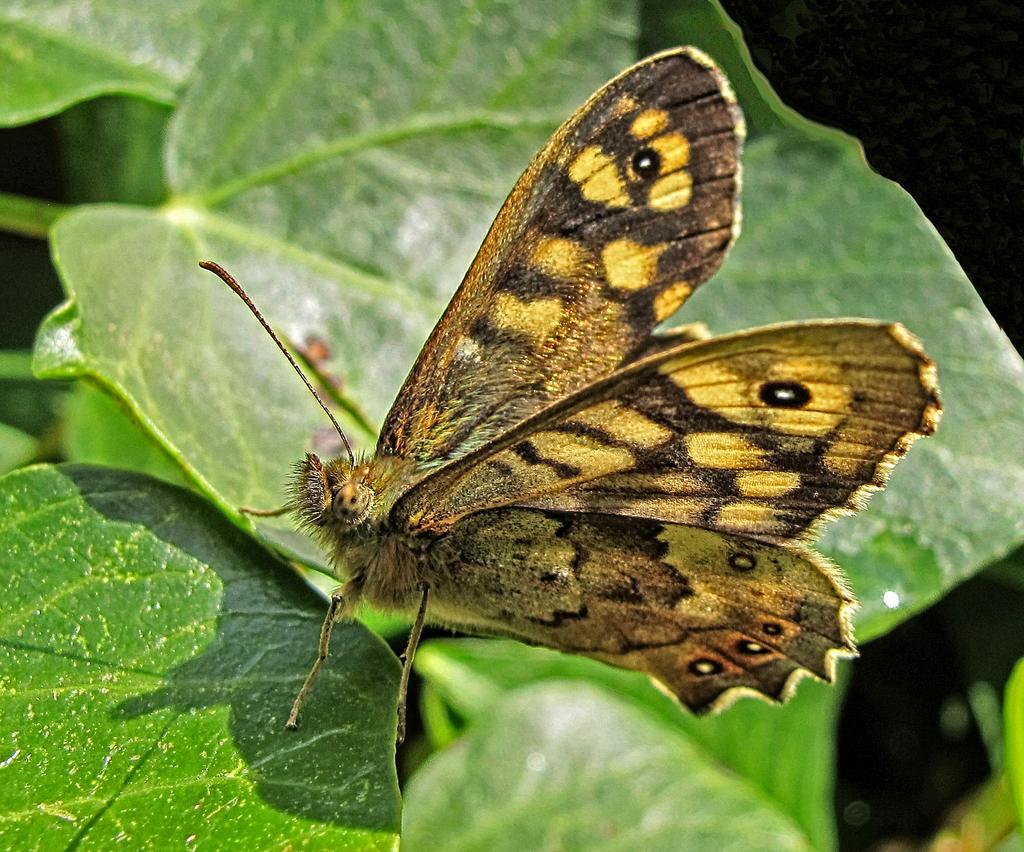What is the main subject in the center of the image? There is a butterfly in the center of the image. What can be seen in the background of the image? Leaves are visible in the background of the image. How would you describe the lighting on the right side of the image? The right side of the image appears to be dark. What type of road can be seen in the image? There is no road present in the image; it features a butterfly and leaves in the background. What territory does the butterfly claim as its own in the image? Butterflies do not claim territories, and there is no indication of territorial behavior in the image. 